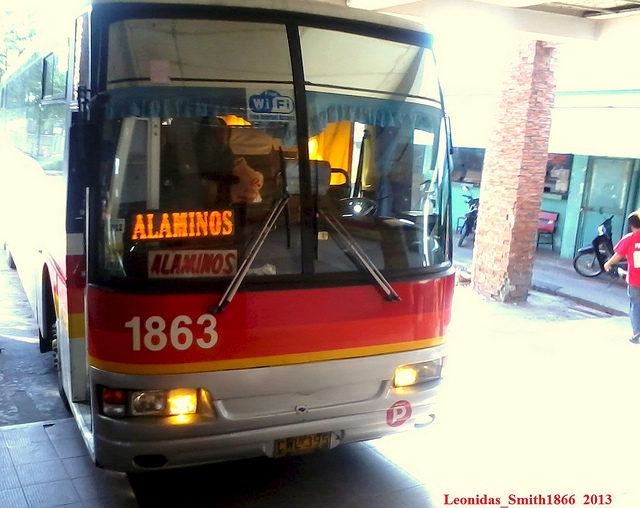What are the metal poles on the window called? The correct answer is C, handles. The metal poles on a bus window, which can be seen here, are referred to as handles. They are used to open and close the window, usually by a sliding mechanism that allows for adjustable ventilation inside the vehicle. 